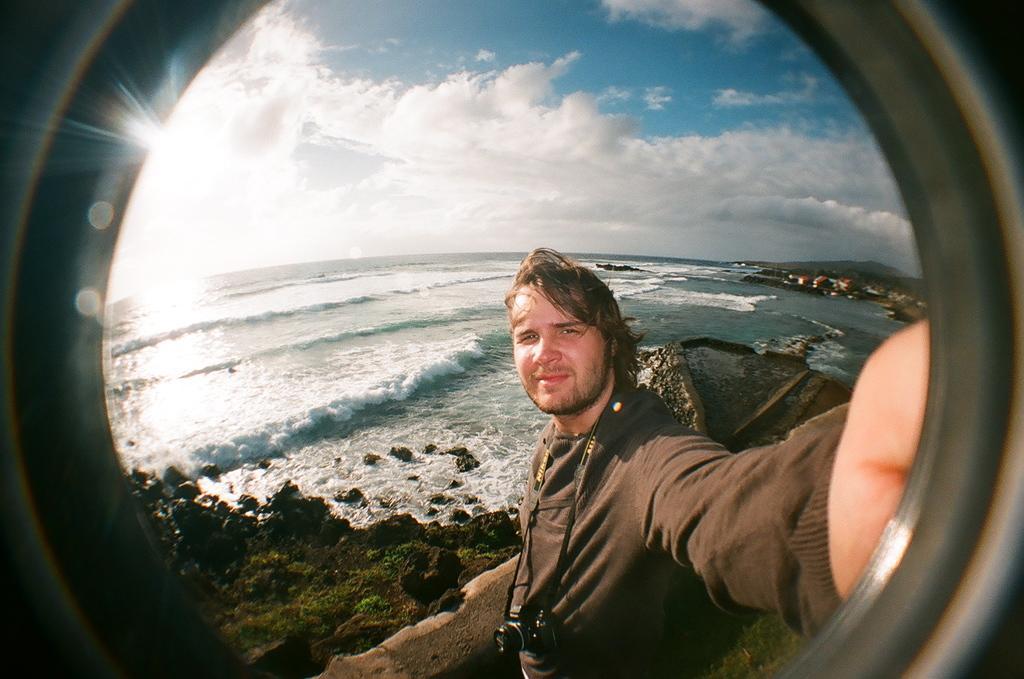How would you summarize this image in a sentence or two? In the foreground of the picture there is a person wearing a camera and holding an object. On the left there are shrubs, stones, water and sun. On the right there are hills, buildings and water. 